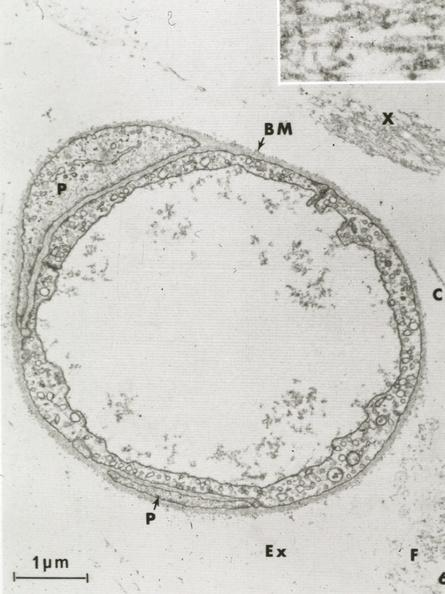s case of peritonitis slide present?
Answer the question using a single word or phrase. No 